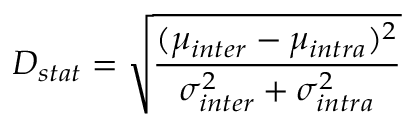Convert formula to latex. <formula><loc_0><loc_0><loc_500><loc_500>D _ { s t a t } = \sqrt { \frac { ( \mu _ { i n t e r } - \mu _ { i n t r a } ) ^ { 2 } } { \sigma _ { i n t e r } ^ { 2 } + \sigma _ { i n t r a } ^ { 2 } } }</formula> 